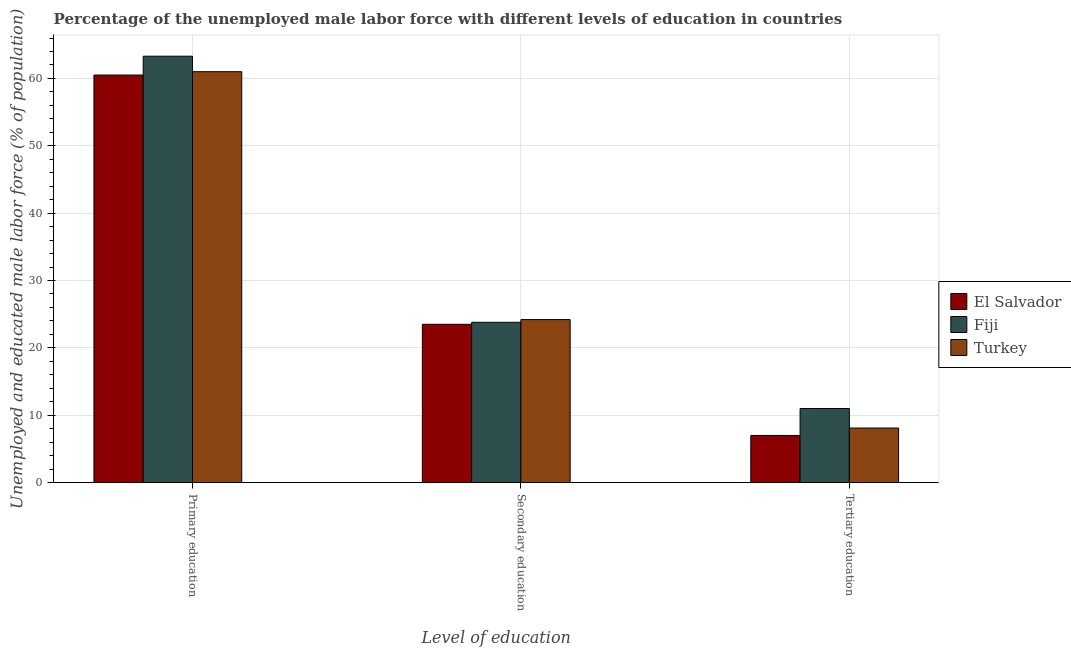Are the number of bars per tick equal to the number of legend labels?
Offer a terse response. Yes. How many bars are there on the 3rd tick from the left?
Make the answer very short. 3. How many bars are there on the 1st tick from the right?
Give a very brief answer. 3. What is the percentage of male labor force who received primary education in Fiji?
Your response must be concise. 63.3. Across all countries, what is the maximum percentage of male labor force who received secondary education?
Your answer should be compact. 24.2. Across all countries, what is the minimum percentage of male labor force who received tertiary education?
Offer a terse response. 7. In which country was the percentage of male labor force who received secondary education maximum?
Ensure brevity in your answer.  Turkey. In which country was the percentage of male labor force who received primary education minimum?
Ensure brevity in your answer.  El Salvador. What is the total percentage of male labor force who received secondary education in the graph?
Provide a succinct answer. 71.5. What is the difference between the percentage of male labor force who received primary education in Fiji and that in El Salvador?
Your answer should be very brief. 2.8. What is the difference between the percentage of male labor force who received primary education in Turkey and the percentage of male labor force who received tertiary education in El Salvador?
Your answer should be very brief. 54. What is the average percentage of male labor force who received primary education per country?
Offer a terse response. 61.6. What is the difference between the percentage of male labor force who received tertiary education and percentage of male labor force who received primary education in Fiji?
Give a very brief answer. -52.3. In how many countries, is the percentage of male labor force who received primary education greater than 42 %?
Keep it short and to the point. 3. What is the ratio of the percentage of male labor force who received primary education in Fiji to that in El Salvador?
Offer a very short reply. 1.05. Is the percentage of male labor force who received secondary education in El Salvador less than that in Turkey?
Ensure brevity in your answer.  Yes. Is the difference between the percentage of male labor force who received secondary education in El Salvador and Turkey greater than the difference between the percentage of male labor force who received tertiary education in El Salvador and Turkey?
Give a very brief answer. Yes. What is the difference between the highest and the second highest percentage of male labor force who received tertiary education?
Provide a succinct answer. 2.9. What is the difference between the highest and the lowest percentage of male labor force who received primary education?
Provide a succinct answer. 2.8. In how many countries, is the percentage of male labor force who received primary education greater than the average percentage of male labor force who received primary education taken over all countries?
Offer a very short reply. 1. Is the sum of the percentage of male labor force who received secondary education in Fiji and El Salvador greater than the maximum percentage of male labor force who received primary education across all countries?
Offer a terse response. No. What does the 1st bar from the left in Secondary education represents?
Provide a succinct answer. El Salvador. What does the 3rd bar from the right in Tertiary education represents?
Offer a terse response. El Salvador. Is it the case that in every country, the sum of the percentage of male labor force who received primary education and percentage of male labor force who received secondary education is greater than the percentage of male labor force who received tertiary education?
Make the answer very short. Yes. How many bars are there?
Your response must be concise. 9. How many countries are there in the graph?
Provide a short and direct response. 3. What is the difference between two consecutive major ticks on the Y-axis?
Offer a terse response. 10. Does the graph contain grids?
Make the answer very short. Yes. How are the legend labels stacked?
Provide a succinct answer. Vertical. What is the title of the graph?
Provide a short and direct response. Percentage of the unemployed male labor force with different levels of education in countries. What is the label or title of the X-axis?
Make the answer very short. Level of education. What is the label or title of the Y-axis?
Your response must be concise. Unemployed and educated male labor force (% of population). What is the Unemployed and educated male labor force (% of population) of El Salvador in Primary education?
Your response must be concise. 60.5. What is the Unemployed and educated male labor force (% of population) in Fiji in Primary education?
Make the answer very short. 63.3. What is the Unemployed and educated male labor force (% of population) in Turkey in Primary education?
Provide a short and direct response. 61. What is the Unemployed and educated male labor force (% of population) of Fiji in Secondary education?
Your response must be concise. 23.8. What is the Unemployed and educated male labor force (% of population) in Turkey in Secondary education?
Your answer should be very brief. 24.2. What is the Unemployed and educated male labor force (% of population) in Turkey in Tertiary education?
Your answer should be very brief. 8.1. Across all Level of education, what is the maximum Unemployed and educated male labor force (% of population) of El Salvador?
Give a very brief answer. 60.5. Across all Level of education, what is the maximum Unemployed and educated male labor force (% of population) of Fiji?
Provide a short and direct response. 63.3. Across all Level of education, what is the maximum Unemployed and educated male labor force (% of population) of Turkey?
Your response must be concise. 61. Across all Level of education, what is the minimum Unemployed and educated male labor force (% of population) of Fiji?
Provide a short and direct response. 11. Across all Level of education, what is the minimum Unemployed and educated male labor force (% of population) of Turkey?
Your answer should be very brief. 8.1. What is the total Unemployed and educated male labor force (% of population) of El Salvador in the graph?
Your response must be concise. 91. What is the total Unemployed and educated male labor force (% of population) of Fiji in the graph?
Provide a succinct answer. 98.1. What is the total Unemployed and educated male labor force (% of population) in Turkey in the graph?
Your answer should be compact. 93.3. What is the difference between the Unemployed and educated male labor force (% of population) of El Salvador in Primary education and that in Secondary education?
Give a very brief answer. 37. What is the difference between the Unemployed and educated male labor force (% of population) in Fiji in Primary education and that in Secondary education?
Give a very brief answer. 39.5. What is the difference between the Unemployed and educated male labor force (% of population) in Turkey in Primary education and that in Secondary education?
Your response must be concise. 36.8. What is the difference between the Unemployed and educated male labor force (% of population) of El Salvador in Primary education and that in Tertiary education?
Keep it short and to the point. 53.5. What is the difference between the Unemployed and educated male labor force (% of population) of Fiji in Primary education and that in Tertiary education?
Offer a very short reply. 52.3. What is the difference between the Unemployed and educated male labor force (% of population) in Turkey in Primary education and that in Tertiary education?
Keep it short and to the point. 52.9. What is the difference between the Unemployed and educated male labor force (% of population) of El Salvador in Secondary education and that in Tertiary education?
Make the answer very short. 16.5. What is the difference between the Unemployed and educated male labor force (% of population) in Fiji in Secondary education and that in Tertiary education?
Give a very brief answer. 12.8. What is the difference between the Unemployed and educated male labor force (% of population) in El Salvador in Primary education and the Unemployed and educated male labor force (% of population) in Fiji in Secondary education?
Offer a very short reply. 36.7. What is the difference between the Unemployed and educated male labor force (% of population) in El Salvador in Primary education and the Unemployed and educated male labor force (% of population) in Turkey in Secondary education?
Keep it short and to the point. 36.3. What is the difference between the Unemployed and educated male labor force (% of population) of Fiji in Primary education and the Unemployed and educated male labor force (% of population) of Turkey in Secondary education?
Offer a terse response. 39.1. What is the difference between the Unemployed and educated male labor force (% of population) in El Salvador in Primary education and the Unemployed and educated male labor force (% of population) in Fiji in Tertiary education?
Provide a short and direct response. 49.5. What is the difference between the Unemployed and educated male labor force (% of population) of El Salvador in Primary education and the Unemployed and educated male labor force (% of population) of Turkey in Tertiary education?
Give a very brief answer. 52.4. What is the difference between the Unemployed and educated male labor force (% of population) of Fiji in Primary education and the Unemployed and educated male labor force (% of population) of Turkey in Tertiary education?
Provide a succinct answer. 55.2. What is the difference between the Unemployed and educated male labor force (% of population) of El Salvador in Secondary education and the Unemployed and educated male labor force (% of population) of Fiji in Tertiary education?
Ensure brevity in your answer.  12.5. What is the difference between the Unemployed and educated male labor force (% of population) in El Salvador in Secondary education and the Unemployed and educated male labor force (% of population) in Turkey in Tertiary education?
Provide a succinct answer. 15.4. What is the difference between the Unemployed and educated male labor force (% of population) of Fiji in Secondary education and the Unemployed and educated male labor force (% of population) of Turkey in Tertiary education?
Keep it short and to the point. 15.7. What is the average Unemployed and educated male labor force (% of population) in El Salvador per Level of education?
Give a very brief answer. 30.33. What is the average Unemployed and educated male labor force (% of population) in Fiji per Level of education?
Your answer should be very brief. 32.7. What is the average Unemployed and educated male labor force (% of population) of Turkey per Level of education?
Give a very brief answer. 31.1. What is the difference between the Unemployed and educated male labor force (% of population) in El Salvador and Unemployed and educated male labor force (% of population) in Turkey in Primary education?
Provide a short and direct response. -0.5. What is the difference between the Unemployed and educated male labor force (% of population) in Fiji and Unemployed and educated male labor force (% of population) in Turkey in Primary education?
Offer a terse response. 2.3. What is the difference between the Unemployed and educated male labor force (% of population) in El Salvador and Unemployed and educated male labor force (% of population) in Fiji in Secondary education?
Keep it short and to the point. -0.3. What is the difference between the Unemployed and educated male labor force (% of population) of Fiji and Unemployed and educated male labor force (% of population) of Turkey in Secondary education?
Make the answer very short. -0.4. What is the ratio of the Unemployed and educated male labor force (% of population) in El Salvador in Primary education to that in Secondary education?
Your answer should be compact. 2.57. What is the ratio of the Unemployed and educated male labor force (% of population) in Fiji in Primary education to that in Secondary education?
Make the answer very short. 2.66. What is the ratio of the Unemployed and educated male labor force (% of population) of Turkey in Primary education to that in Secondary education?
Your answer should be very brief. 2.52. What is the ratio of the Unemployed and educated male labor force (% of population) of El Salvador in Primary education to that in Tertiary education?
Give a very brief answer. 8.64. What is the ratio of the Unemployed and educated male labor force (% of population) in Fiji in Primary education to that in Tertiary education?
Your answer should be compact. 5.75. What is the ratio of the Unemployed and educated male labor force (% of population) in Turkey in Primary education to that in Tertiary education?
Offer a very short reply. 7.53. What is the ratio of the Unemployed and educated male labor force (% of population) of El Salvador in Secondary education to that in Tertiary education?
Offer a terse response. 3.36. What is the ratio of the Unemployed and educated male labor force (% of population) in Fiji in Secondary education to that in Tertiary education?
Your answer should be very brief. 2.16. What is the ratio of the Unemployed and educated male labor force (% of population) in Turkey in Secondary education to that in Tertiary education?
Make the answer very short. 2.99. What is the difference between the highest and the second highest Unemployed and educated male labor force (% of population) in Fiji?
Your answer should be very brief. 39.5. What is the difference between the highest and the second highest Unemployed and educated male labor force (% of population) of Turkey?
Offer a terse response. 36.8. What is the difference between the highest and the lowest Unemployed and educated male labor force (% of population) in El Salvador?
Your answer should be very brief. 53.5. What is the difference between the highest and the lowest Unemployed and educated male labor force (% of population) of Fiji?
Your answer should be very brief. 52.3. What is the difference between the highest and the lowest Unemployed and educated male labor force (% of population) of Turkey?
Offer a terse response. 52.9. 